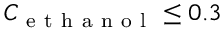<formula> <loc_0><loc_0><loc_500><loc_500>C _ { e t h a n o l } \leq 0 . 3</formula> 